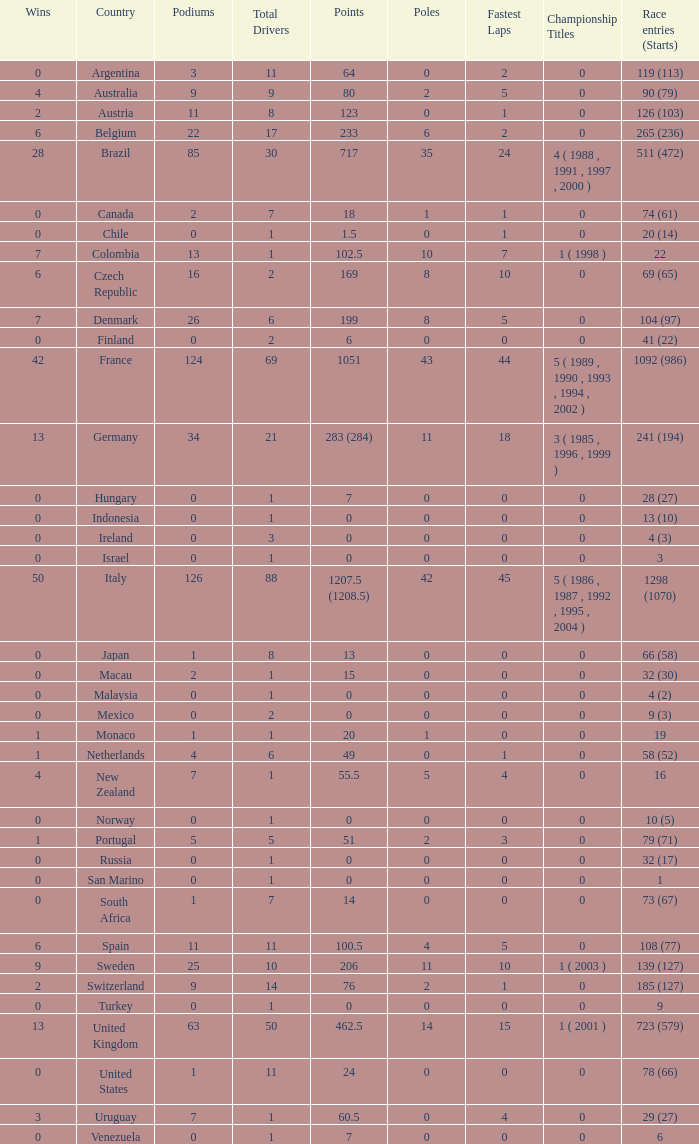How many fastest laps for the nation with 32 (30) entries and starts and fewer than 2 podiums? None. 